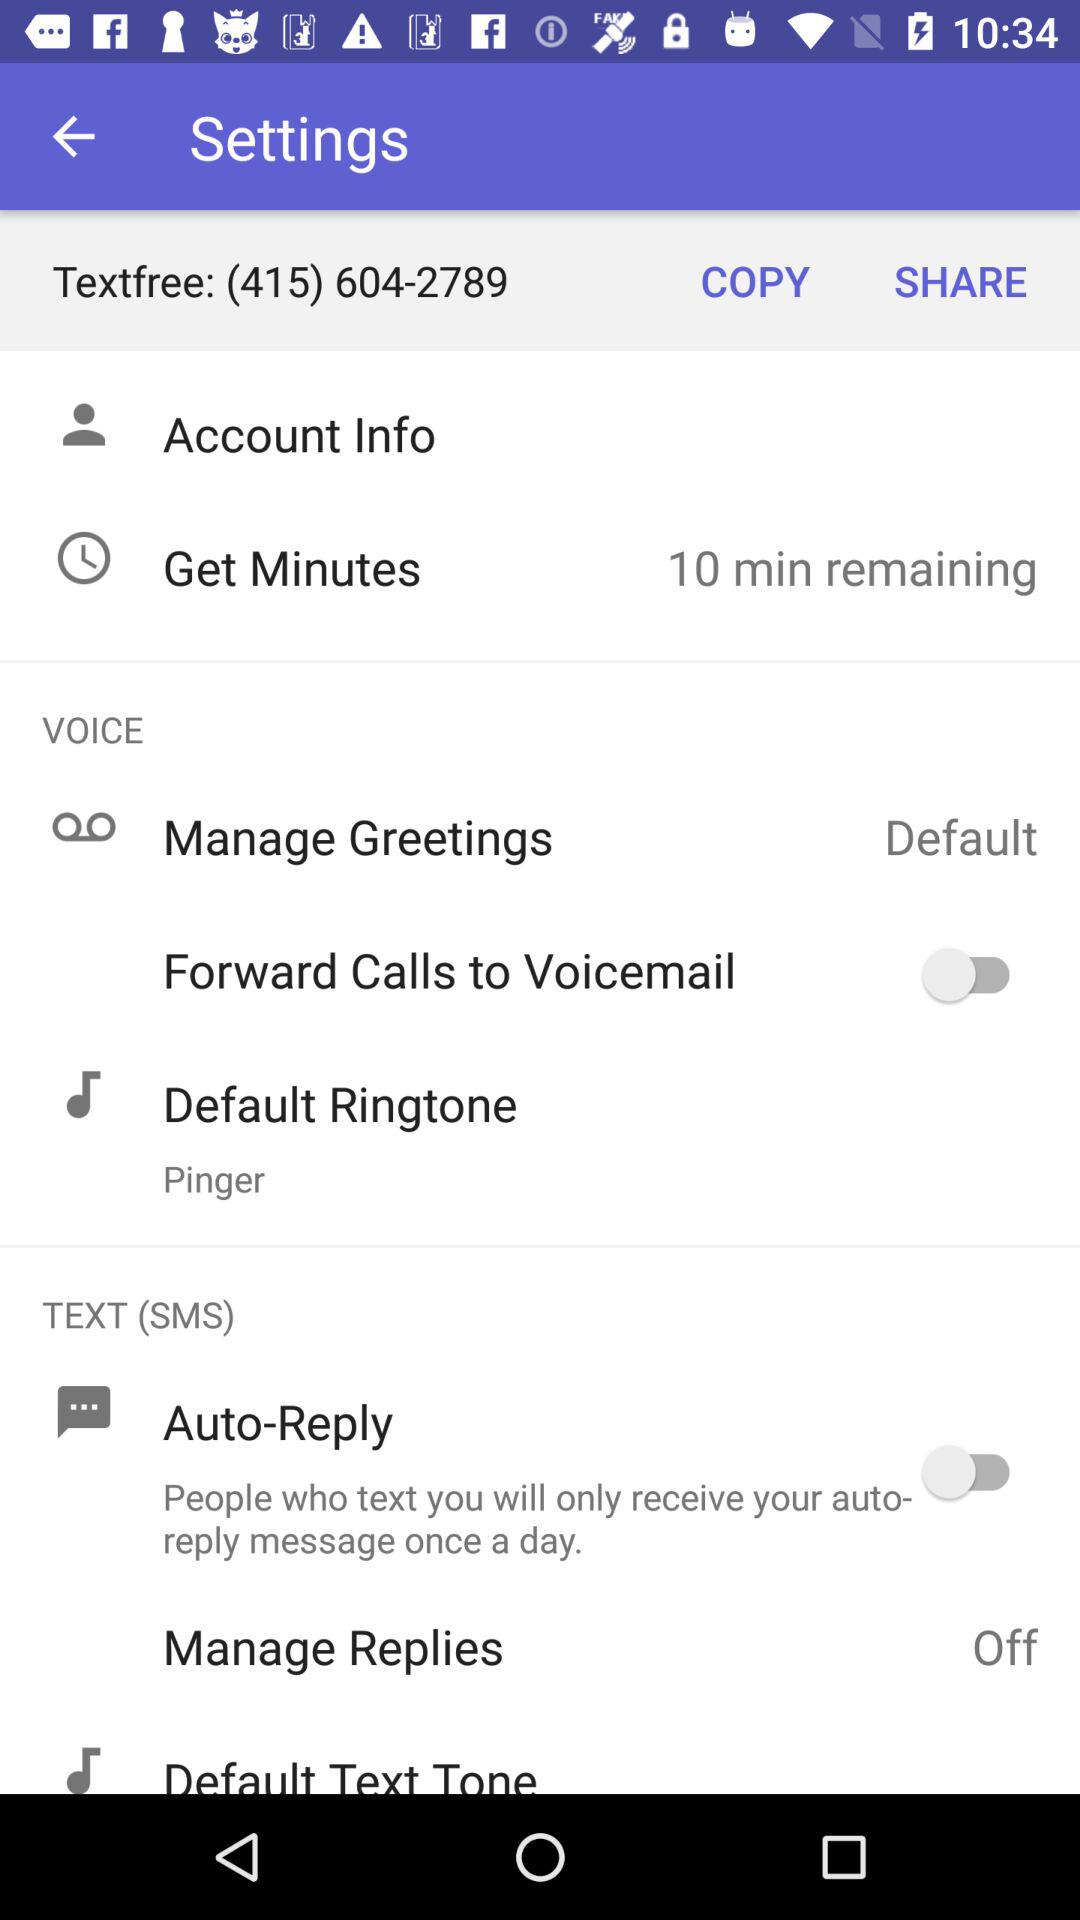How many minutes are remaining? There are 10 minutes remaining. 